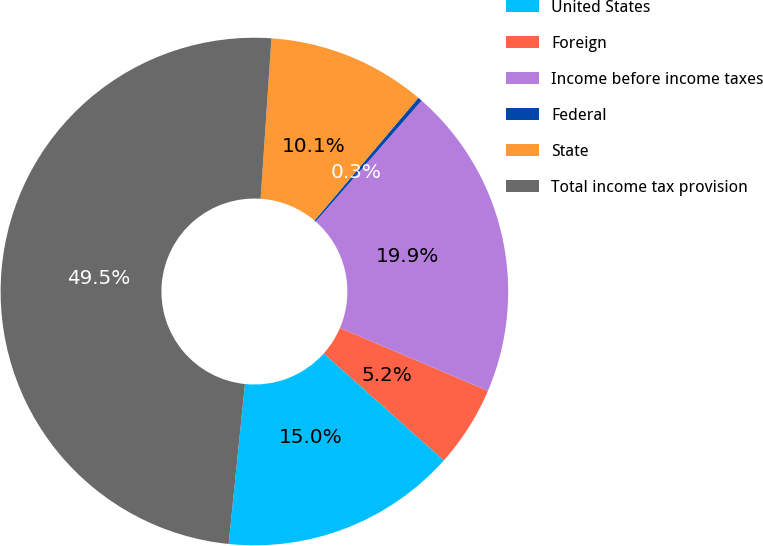Convert chart. <chart><loc_0><loc_0><loc_500><loc_500><pie_chart><fcel>United States<fcel>Foreign<fcel>Income before income taxes<fcel>Federal<fcel>State<fcel>Total income tax provision<nl><fcel>15.03%<fcel>5.19%<fcel>19.95%<fcel>0.27%<fcel>10.11%<fcel>49.46%<nl></chart> 